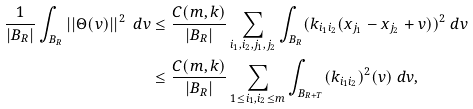Convert formula to latex. <formula><loc_0><loc_0><loc_500><loc_500>\frac { 1 } { | B _ { R } | } \int _ { B _ { R } } | | \Theta ( v ) | | ^ { 2 } \ d v & \leq \frac { C ( m , k ) } { | B _ { R } | } \sum _ { i _ { 1 } , i _ { 2 } , j _ { 1 } , j _ { 2 } } \int _ { B _ { R } } ( k _ { i _ { 1 } i _ { 2 } } ( x _ { j _ { 1 } } - x _ { j _ { 2 } } + v ) ) ^ { 2 } \ d v \\ & \leq \frac { C ( m , k ) } { | B _ { R } | } \sum _ { 1 \leq i _ { 1 } , i _ { 2 } \leq m } \int _ { B _ { R + T } } ( k _ { i _ { 1 } i _ { 2 } } ) ^ { 2 } ( v ) \ d v ,</formula> 